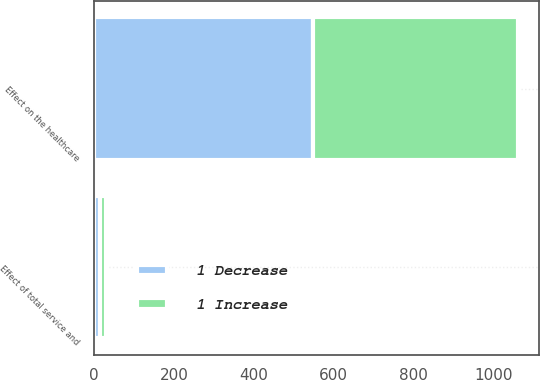Convert chart to OTSL. <chart><loc_0><loc_0><loc_500><loc_500><stacked_bar_chart><ecel><fcel>Effect of total service and<fcel>Effect on the healthcare<nl><fcel>1 Decrease<fcel>15<fcel>549<nl><fcel>1 Increase<fcel>14<fcel>511<nl></chart> 